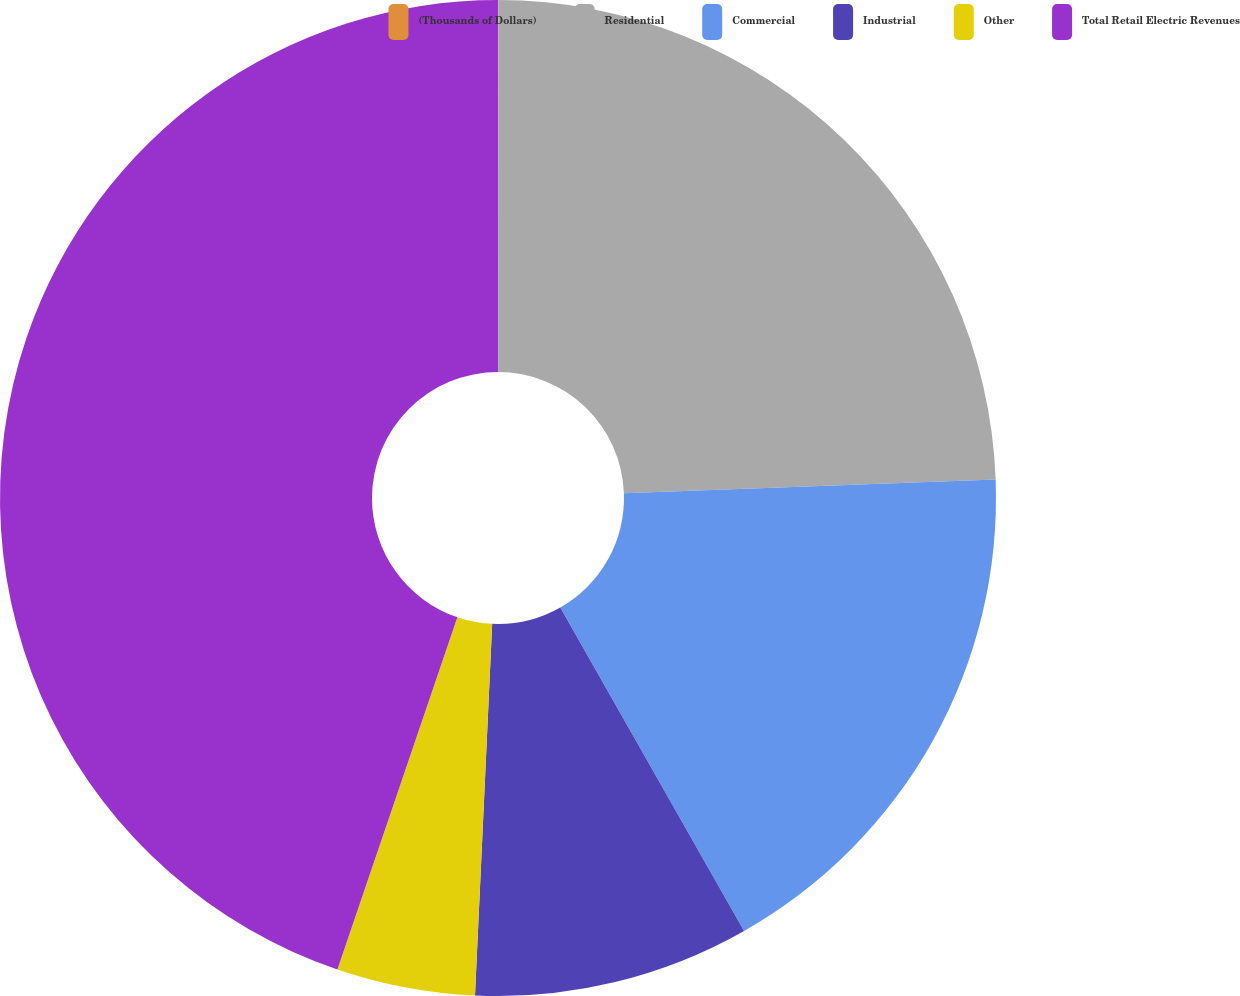Convert chart to OTSL. <chart><loc_0><loc_0><loc_500><loc_500><pie_chart><fcel>(Thousands of Dollars)<fcel>Residential<fcel>Commercial<fcel>Industrial<fcel>Other<fcel>Total Retail Electric Revenues<nl><fcel>0.01%<fcel>24.4%<fcel>17.36%<fcel>8.96%<fcel>4.49%<fcel>44.77%<nl></chart> 